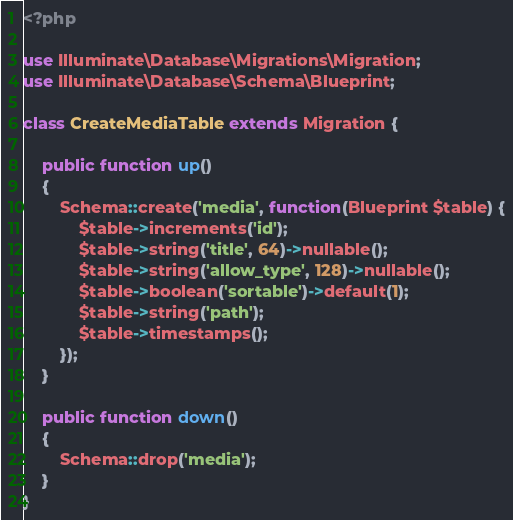<code> <loc_0><loc_0><loc_500><loc_500><_PHP_><?php

use Illuminate\Database\Migrations\Migration;
use Illuminate\Database\Schema\Blueprint;

class CreateMediaTable extends Migration {

	public function up()
	{
		Schema::create('media', function(Blueprint $table) {
			$table->increments('id');
			$table->string('title', 64)->nullable();
			$table->string('allow_type', 128)->nullable();
			$table->boolean('sortable')->default(1);
			$table->string('path');
			$table->timestamps();
		});
	}

	public function down()
	{
		Schema::drop('media');
	}
}
</code> 